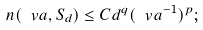<formula> <loc_0><loc_0><loc_500><loc_500>n ( \ v a , S _ { d } ) \leq C d ^ { q } ( \ v a ^ { - 1 } ) ^ { p } ;</formula> 